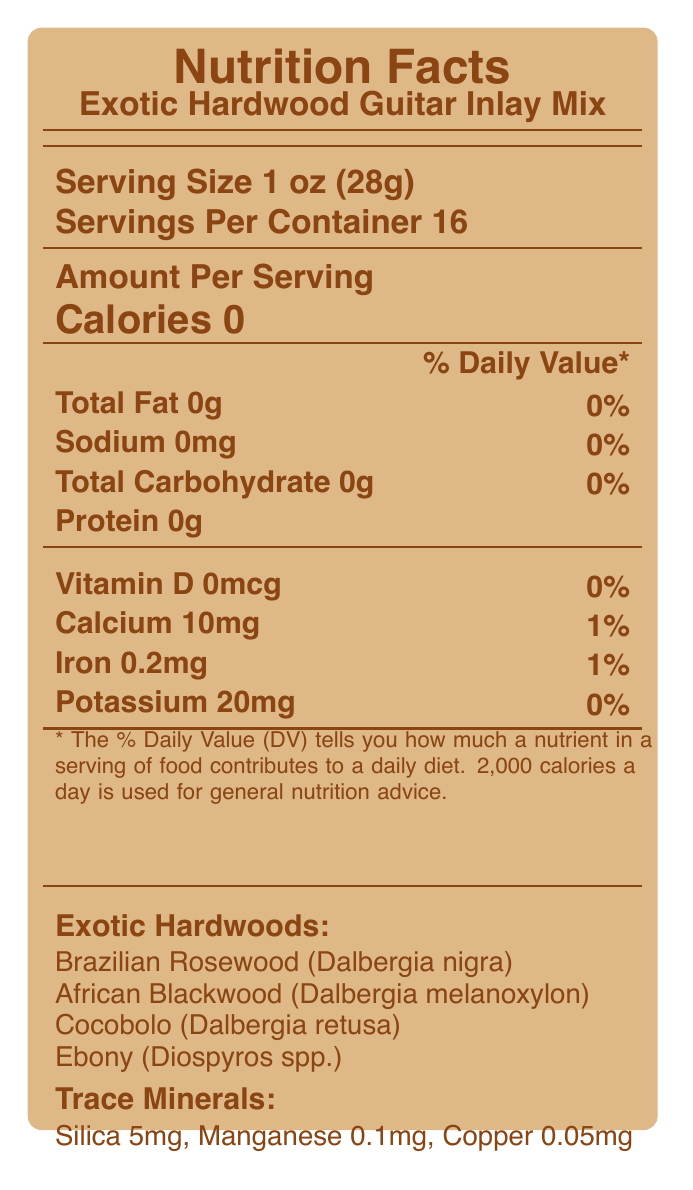what is the serving size for the Exotic Hardwood Guitar Inlay Mix? The serving size is listed directly under the product name and it states "Serving Size 1 oz (28g)”.
Answer: 1 oz (28g) how many calories are there per serving? The label lists "Calories 0" next to "Amount Per Serving".
Answer: 0 what is the density of African Blackwood? African Blackwood has a density of 1.3 g/cm³ as noted under the "Exotic Hardwoods" section.
Answer: 1.3 g/cm³ which hardwood has the highest Janka Hardness value? The Janka Hardness listed ranges from 2200-3800 lbf; African Blackwood has the highest density which is indicative of high hardness.
Answer: African Blackwood how much calcium is there per serving? Under the nutrient section, “Calcium 10mg” is stated along with its Daily Value percentage.
Answer: 10mg does the Exotic Hardwood Guitar Inlay Mix contain any protein? The nutrient section states "Protein 0g", confirming there is no protein in the product.
Answer: No which of the following is a sustainable alternative to exotic hardwoods? A. Cocobolo B. African Blackwood C. Katalox D. Ebony The "sustainable alternatives" section lists Katalox, unlike the others.
Answer: C. Katalox how many servings are there per container? The serving information states "Servings Per Container 16".
Answer: 16 what trace mineral is present in the greatest amount? A. Silica B. Manganese C. Copper The trace mineral amounts are given and Silica is listed as 5mg, the highest among the given minerals.
Answer: A. Silica what precaution should be taken when working with exotic hardwoods? The craftsman notes mention "Use N95 respirator when working with exotic hardwoods" under dust precautions.
Answer: Use N95 respirator is Brazilian Rosewood listed under endangered species? The document states Brazilian Rosewood is listed under endangered species.
Answer: Yes describe the main idea of the document. The document details various aspects of Exotic Hardwood Guitar Inlay Mix, covering nutritional content, exotic hardwood specifications such as density and woodworking properties, sustainability status, trace minerals, and safety guidelines for craftsmen working with the materials.
Answer: The document provides detailed nutritional information, density, properties, sustainability and safety notes for Exotic Hardwood Guitar Inlay Mix, including specific wood types and trace minerals. what is the percentage of the daily value for Iron in one serving? The label lists "Iron 0.2mg" which corresponds to 1% of the daily value.
Answer: 1% what woodworking technique can enhance grain patterns? The finishing recommendations in the craftsman notes mention "Oil-based finishes enhance grain patterns".
Answer: Oil-based finishes which exotic hardwoods are included in the Guitar Inlay Mix? These exotic hardwoods are listed under the "Exotic Hardwoods" section of the document.
Answer: Brazilian Rosewood, African Blackwood, Cocobolo, Ebony what is the total carbohydrate content per serving? The nutrition facts section lists "Total Carbohydrate 0g".
Answer: 0g what is the grain pattern range of the exotic hardwoods listed? The woodworking properties section mentions "Grain Pattern: Straight to interlocked".
Answer: Straight to interlocked what is the oil content of the exotic hardwoods? The woodworking properties mention a high oil content under the oil content property.
Answer: High when working with exotic hardwoods, what is recommended to be used to prevent health issues? The dust precautions in the craftsman notes recommend using an N95 respirator.
Answer: N95 respirator what is the scientific name of Ebony? Under the exotic hardwoods section, Ebony is stated as having the scientific name Diospyros spp.
Answer: Diospyros spp. which exotic hardwood has the lowest density? A. Brazilian Rosewood B. African Blackwood C. Cocobolo Brazilian Rosewood has a density of 0.85 g/cm³, which is lower compared to African Blackwood and Cocobolo.
Answer: A. Brazilian Rosewood how does the oil content of the exotic hardwoods potentially affect the woodworking process? The woodworking properties mention that the high oil content may affect glue adhesion, indicating potential challenges in the woodworking process.
Answer: May affect glue adhesion are these nutrition facts typical for all hardwoods? The document only provides nutrition facts for the specified Exotic Hardwood Guitar Inlay Mix and does not offer information on other types of hardwoods.
Answer: Not enough information 